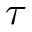<formula> <loc_0><loc_0><loc_500><loc_500>\tau</formula> 